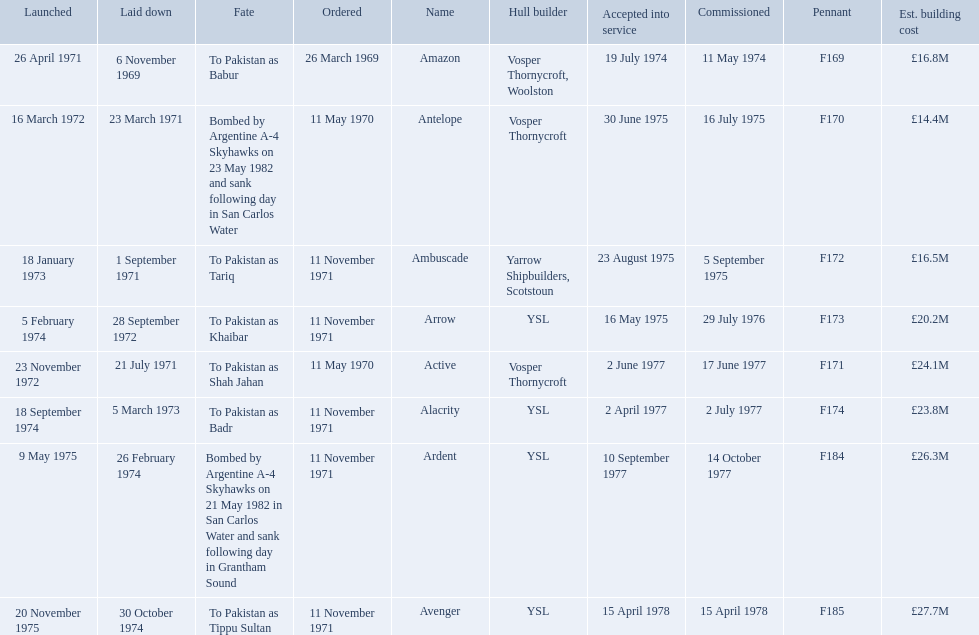What were the estimated building costs of the frigates? £16.8M, £14.4M, £16.5M, £20.2M, £24.1M, £23.8M, £26.3M, £27.7M. Which of these is the largest? £27.7M. What ship name does that correspond to? Avenger. 